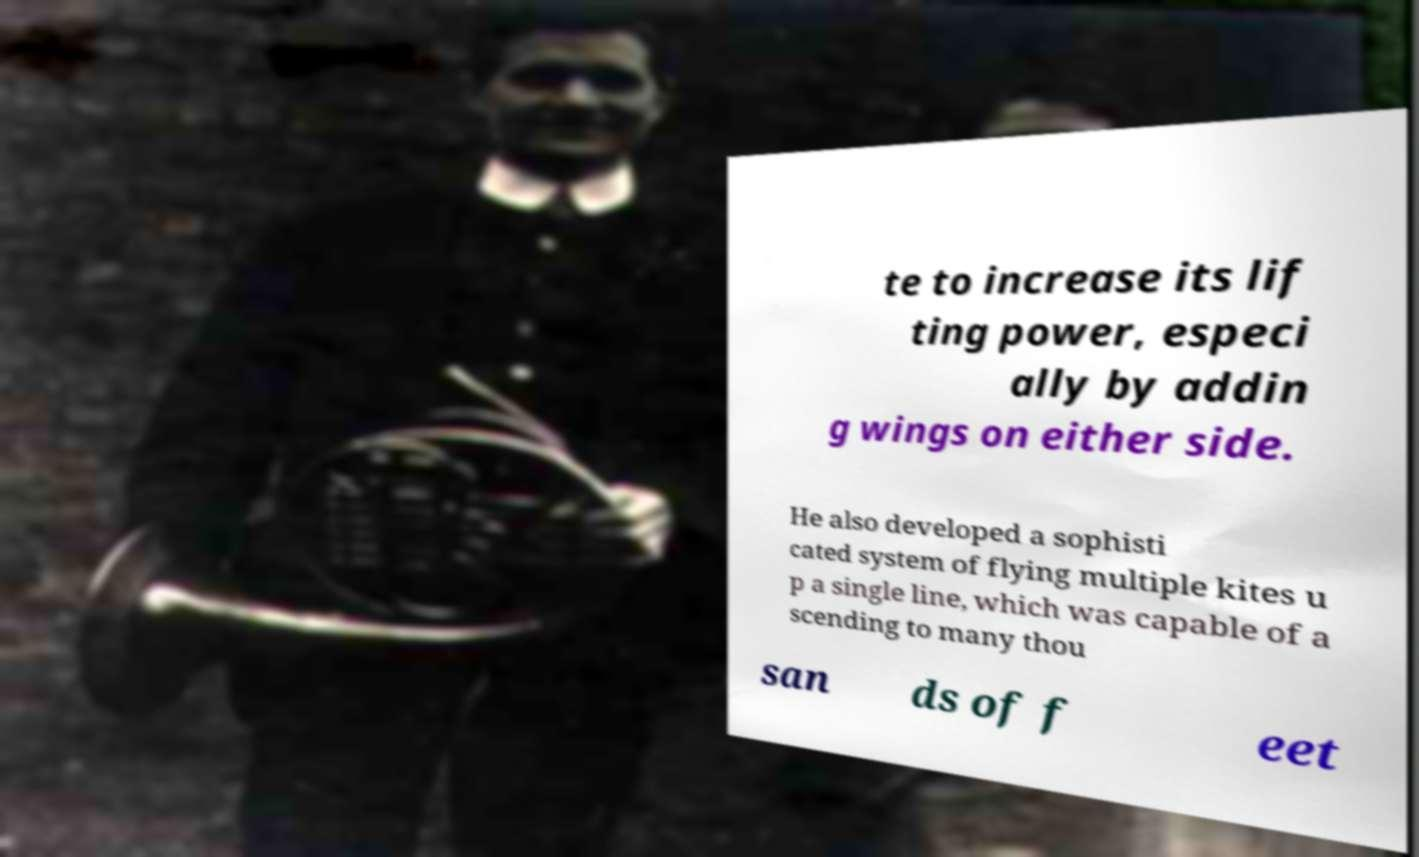For documentation purposes, I need the text within this image transcribed. Could you provide that? te to increase its lif ting power, especi ally by addin g wings on either side. He also developed a sophisti cated system of flying multiple kites u p a single line, which was capable of a scending to many thou san ds of f eet 